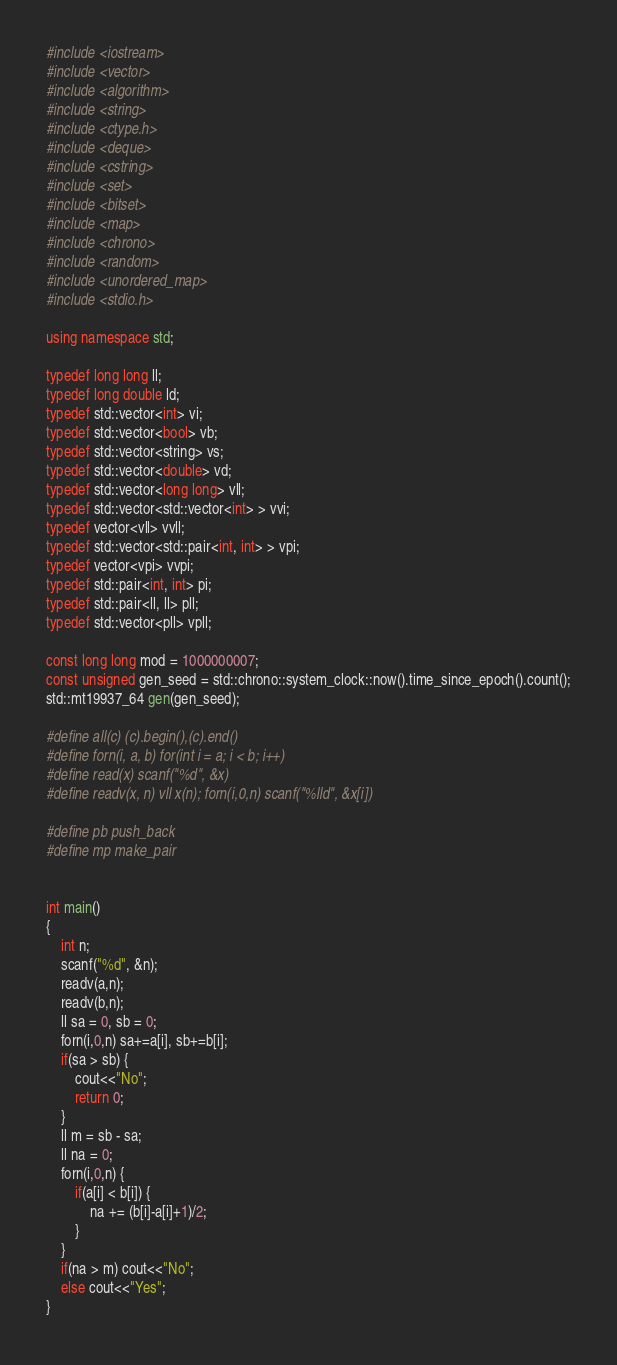<code> <loc_0><loc_0><loc_500><loc_500><_C++_>#include <iostream>
#include <vector>
#include <algorithm>
#include <string>
#include <ctype.h>
#include <deque>
#include <cstring>
#include <set>
#include <bitset>
#include <map>
#include <chrono>
#include <random>
#include <unordered_map>
#include <stdio.h>

using namespace std;

typedef long long ll;
typedef long double ld;
typedef std::vector<int> vi;
typedef std::vector<bool> vb;
typedef std::vector<string> vs;
typedef std::vector<double> vd;
typedef std::vector<long long> vll;
typedef std::vector<std::vector<int> > vvi;
typedef vector<vll> vvll;
typedef std::vector<std::pair<int, int> > vpi;
typedef vector<vpi> vvpi;
typedef std::pair<int, int> pi;
typedef std::pair<ll, ll> pll;
typedef std::vector<pll> vpll;

const long long mod = 1000000007;
const unsigned gen_seed = std::chrono::system_clock::now().time_since_epoch().count();
std::mt19937_64 gen(gen_seed);

#define all(c) (c).begin(),(c).end()
#define forn(i, a, b) for(int i = a; i < b; i++)
#define read(x) scanf("%d", &x)
#define readv(x, n) vll x(n); forn(i,0,n) scanf("%lld", &x[i])

#define pb push_back
#define mp make_pair


int main()
{
    int n;
    scanf("%d", &n);
    readv(a,n);
    readv(b,n);
    ll sa = 0, sb = 0;
    forn(i,0,n) sa+=a[i], sb+=b[i];
    if(sa > sb) {
        cout<<"No";
        return 0;
    }
    ll m = sb - sa;
    ll na = 0;
    forn(i,0,n) {
        if(a[i] < b[i]) {
            na += (b[i]-a[i]+1)/2;
        }
    }
    if(na > m) cout<<"No";
    else cout<<"Yes";
}
</code> 